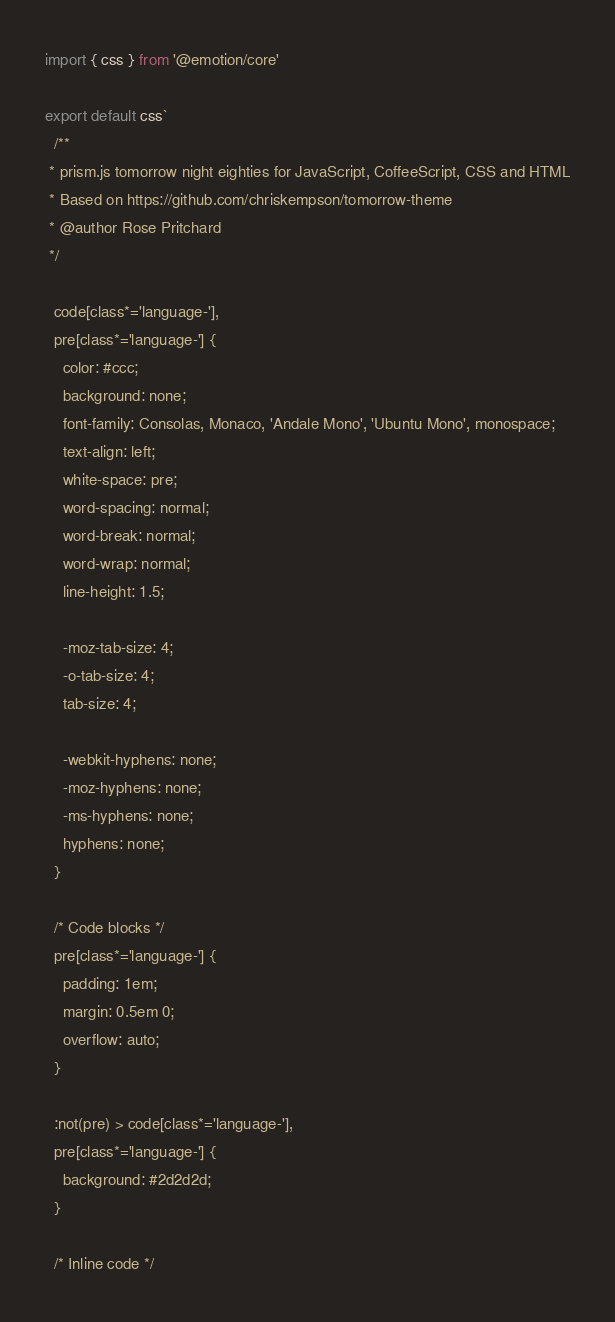Convert code to text. <code><loc_0><loc_0><loc_500><loc_500><_JavaScript_>import { css } from '@emotion/core'

export default css`
  /**
 * prism.js tomorrow night eighties for JavaScript, CoffeeScript, CSS and HTML
 * Based on https://github.com/chriskempson/tomorrow-theme
 * @author Rose Pritchard
 */

  code[class*='language-'],
  pre[class*='language-'] {
    color: #ccc;
    background: none;
    font-family: Consolas, Monaco, 'Andale Mono', 'Ubuntu Mono', monospace;
    text-align: left;
    white-space: pre;
    word-spacing: normal;
    word-break: normal;
    word-wrap: normal;
    line-height: 1.5;

    -moz-tab-size: 4;
    -o-tab-size: 4;
    tab-size: 4;

    -webkit-hyphens: none;
    -moz-hyphens: none;
    -ms-hyphens: none;
    hyphens: none;
  }

  /* Code blocks */
  pre[class*='language-'] {
    padding: 1em;
    margin: 0.5em 0;
    overflow: auto;
  }

  :not(pre) > code[class*='language-'],
  pre[class*='language-'] {
    background: #2d2d2d;
  }

  /* Inline code */</code> 